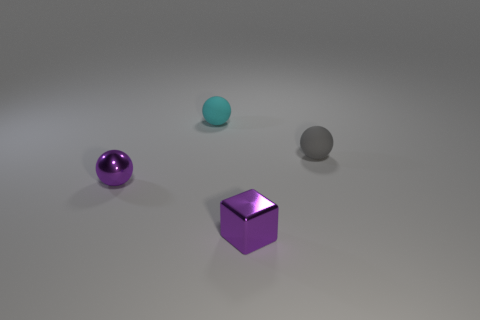Subtract all matte spheres. How many spheres are left? 1 Add 4 small cyan objects. How many objects exist? 8 Subtract all gray balls. How many balls are left? 2 Subtract all spheres. How many objects are left? 1 Subtract 1 cubes. How many cubes are left? 0 Subtract all big green rubber blocks. Subtract all gray matte spheres. How many objects are left? 3 Add 4 cyan balls. How many cyan balls are left? 5 Add 2 large red shiny things. How many large red shiny things exist? 2 Subtract 0 red spheres. How many objects are left? 4 Subtract all brown blocks. Subtract all purple cylinders. How many blocks are left? 1 